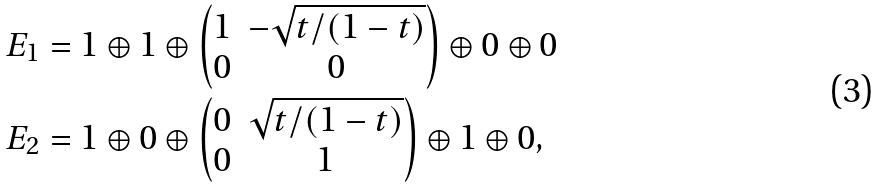<formula> <loc_0><loc_0><loc_500><loc_500>E _ { 1 } & = 1 \oplus 1 \oplus \begin{pmatrix} 1 & - \sqrt { t / ( 1 - t ) } \\ 0 & 0 \end{pmatrix} \oplus 0 \oplus 0 \\ E _ { 2 } & = 1 \oplus 0 \oplus \begin{pmatrix} 0 & \sqrt { t / ( 1 - t ) } \\ 0 & 1 \end{pmatrix} \oplus 1 \oplus 0 ,</formula> 